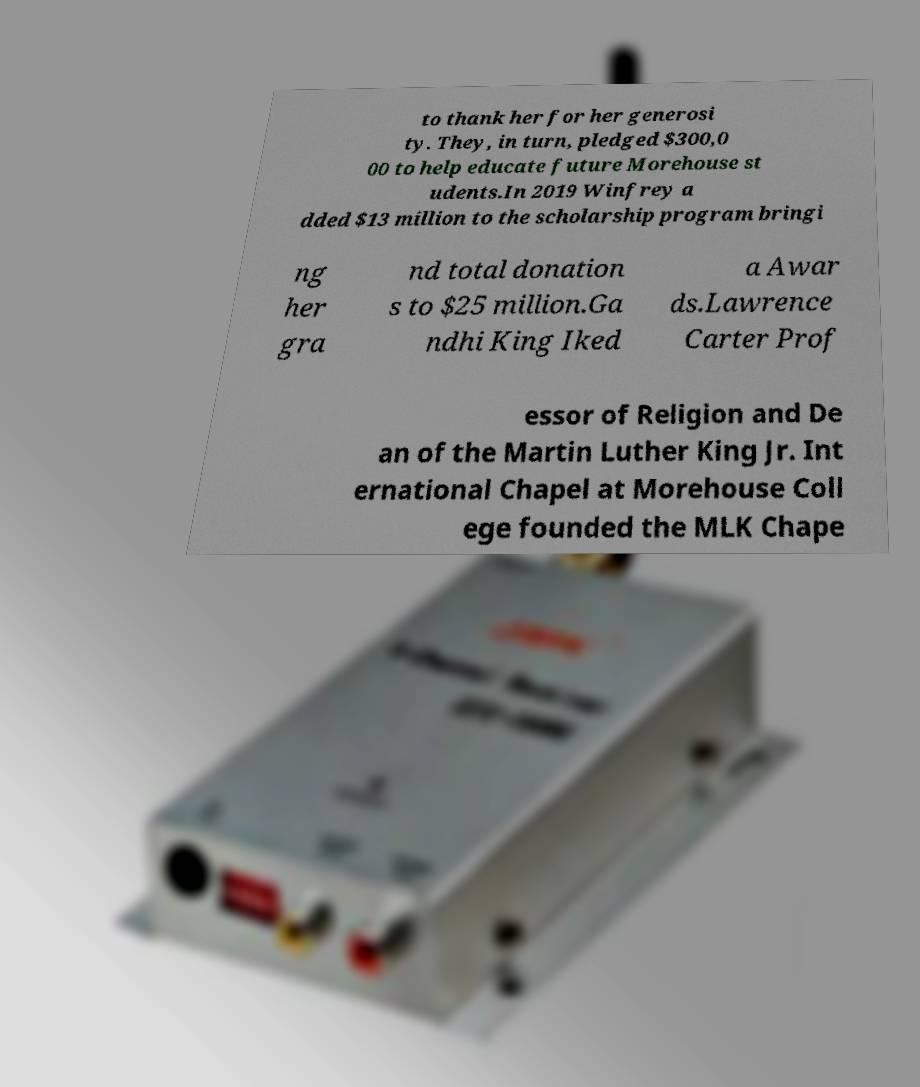What messages or text are displayed in this image? I need them in a readable, typed format. to thank her for her generosi ty. They, in turn, pledged $300,0 00 to help educate future Morehouse st udents.In 2019 Winfrey a dded $13 million to the scholarship program bringi ng her gra nd total donation s to $25 million.Ga ndhi King Iked a Awar ds.Lawrence Carter Prof essor of Religion and De an of the Martin Luther King Jr. Int ernational Chapel at Morehouse Coll ege founded the MLK Chape 